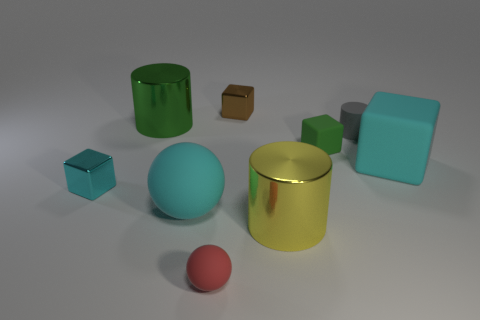There is a big rubber object on the right side of the large yellow object; does it have the same shape as the green metallic object?
Your answer should be very brief. No. What number of objects are small yellow metallic cubes or yellow metallic things?
Ensure brevity in your answer.  1. What is the big thing that is in front of the small cyan thing and behind the big yellow metallic object made of?
Ensure brevity in your answer.  Rubber. Do the cyan shiny object and the red rubber ball have the same size?
Your answer should be compact. Yes. How big is the green thing left of the tiny metallic cube on the right side of the cyan metallic cube?
Give a very brief answer. Large. How many objects are both on the left side of the tiny brown object and behind the tiny green thing?
Your answer should be very brief. 1. There is a big rubber thing that is to the right of the large cylinder that is to the right of the brown shiny thing; are there any tiny red balls that are behind it?
Ensure brevity in your answer.  No. There is a red thing that is the same size as the gray thing; what shape is it?
Your answer should be compact. Sphere. Is there a tiny sphere that has the same color as the tiny cylinder?
Offer a very short reply. No. Is the red matte thing the same shape as the tiny gray matte thing?
Keep it short and to the point. No. 